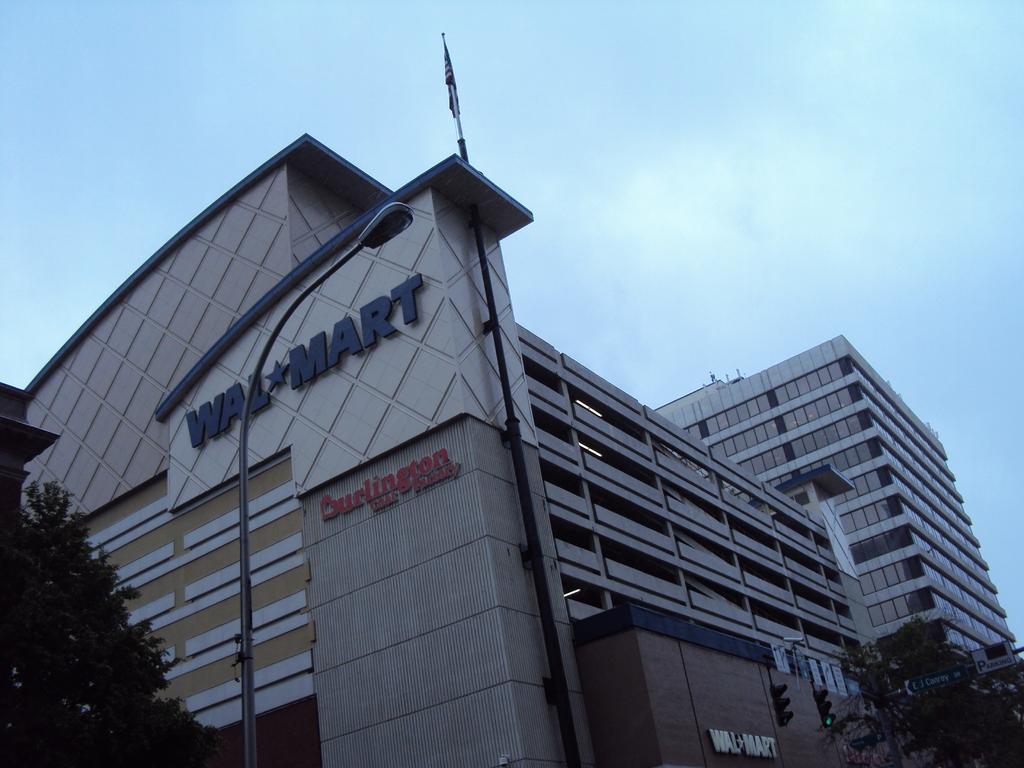Please provide a concise description of this image. This picture shows a building and we see couple of trees and a blue cloudy Sky and we see a pole light and a flag on the building and we see couple of traffic signal lights. 